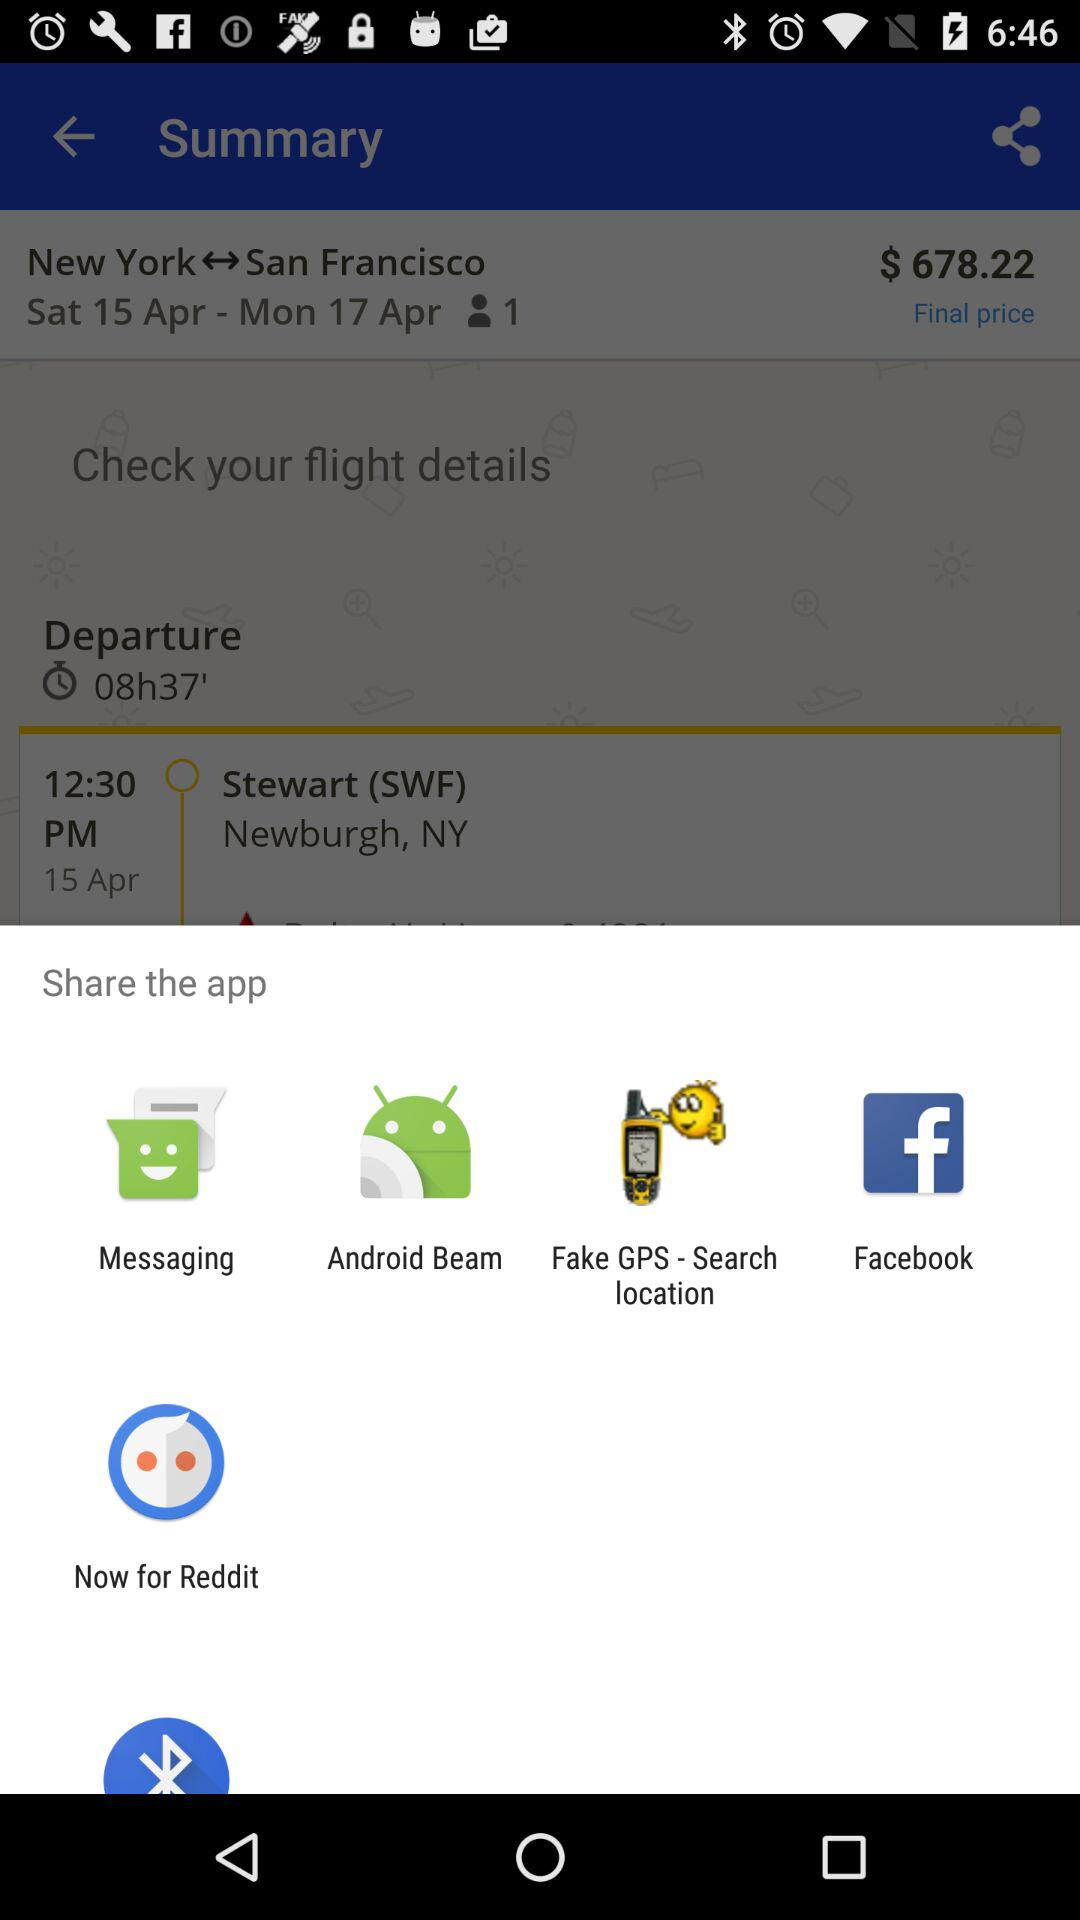What is the currency of the price? The currency of the price is dollars. 